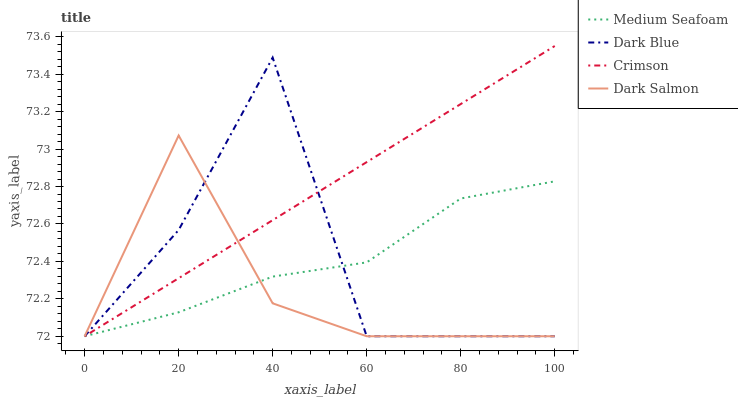Does Dark Salmon have the minimum area under the curve?
Answer yes or no. Yes. Does Crimson have the maximum area under the curve?
Answer yes or no. Yes. Does Dark Blue have the minimum area under the curve?
Answer yes or no. No. Does Dark Blue have the maximum area under the curve?
Answer yes or no. No. Is Crimson the smoothest?
Answer yes or no. Yes. Is Dark Blue the roughest?
Answer yes or no. Yes. Is Medium Seafoam the smoothest?
Answer yes or no. No. Is Medium Seafoam the roughest?
Answer yes or no. No. Does Crimson have the lowest value?
Answer yes or no. Yes. Does Crimson have the highest value?
Answer yes or no. Yes. Does Dark Blue have the highest value?
Answer yes or no. No. Does Dark Salmon intersect Medium Seafoam?
Answer yes or no. Yes. Is Dark Salmon less than Medium Seafoam?
Answer yes or no. No. Is Dark Salmon greater than Medium Seafoam?
Answer yes or no. No. 